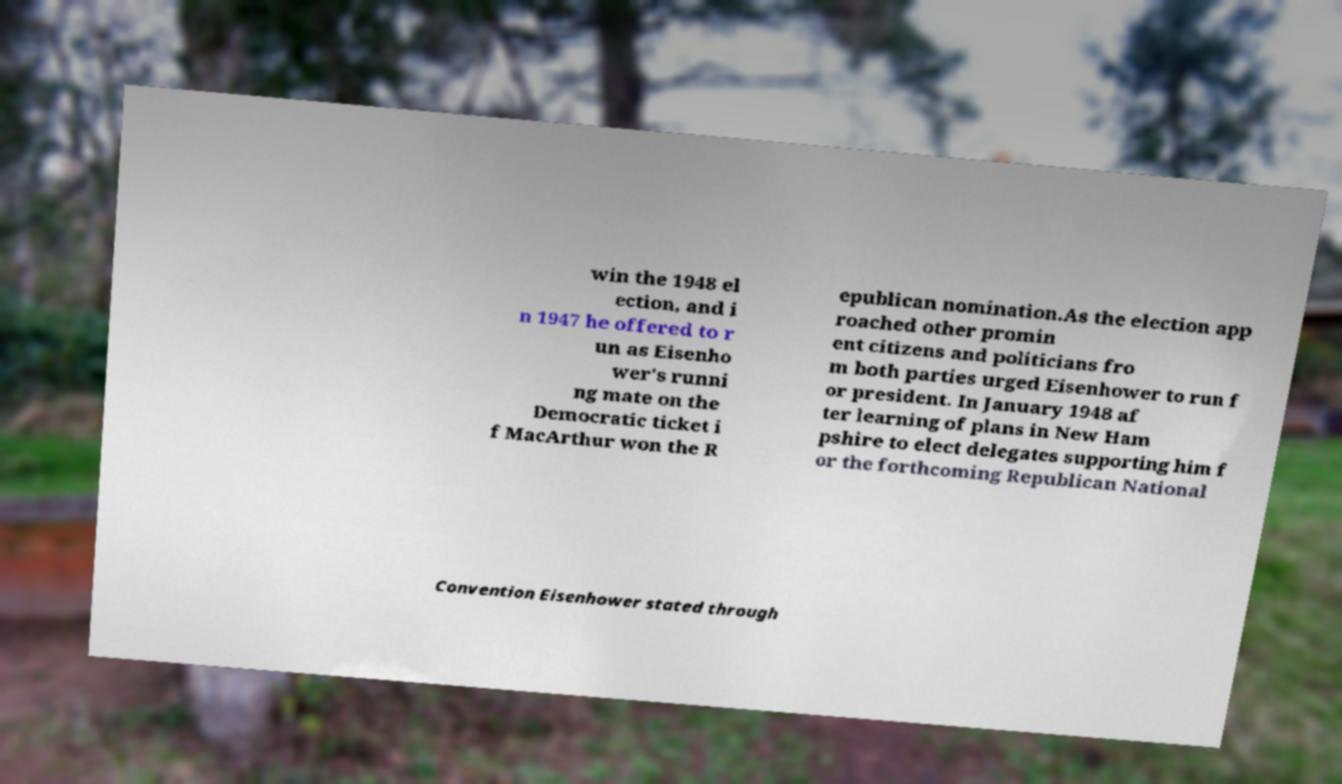What messages or text are displayed in this image? I need them in a readable, typed format. win the 1948 el ection, and i n 1947 he offered to r un as Eisenho wer's runni ng mate on the Democratic ticket i f MacArthur won the R epublican nomination.As the election app roached other promin ent citizens and politicians fro m both parties urged Eisenhower to run f or president. In January 1948 af ter learning of plans in New Ham pshire to elect delegates supporting him f or the forthcoming Republican National Convention Eisenhower stated through 